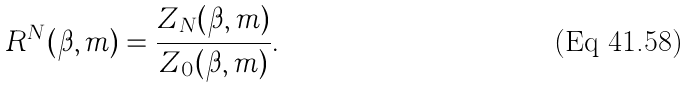Convert formula to latex. <formula><loc_0><loc_0><loc_500><loc_500>R ^ { N } ( \beta , m ) = \frac { Z _ { N } ( \beta , m ) } { Z _ { 0 } ( \beta , m ) } .</formula> 